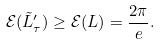<formula> <loc_0><loc_0><loc_500><loc_500>\mathcal { E } ( \tilde { L } ^ { \prime } _ { \tau } ) \geq \mathcal { E } ( L ) = \frac { 2 \pi } { e } .</formula> 